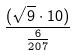<formula> <loc_0><loc_0><loc_500><loc_500>\frac { ( \sqrt { 9 } \cdot 1 0 ) } { \frac { 6 } { 2 0 7 } }</formula> 